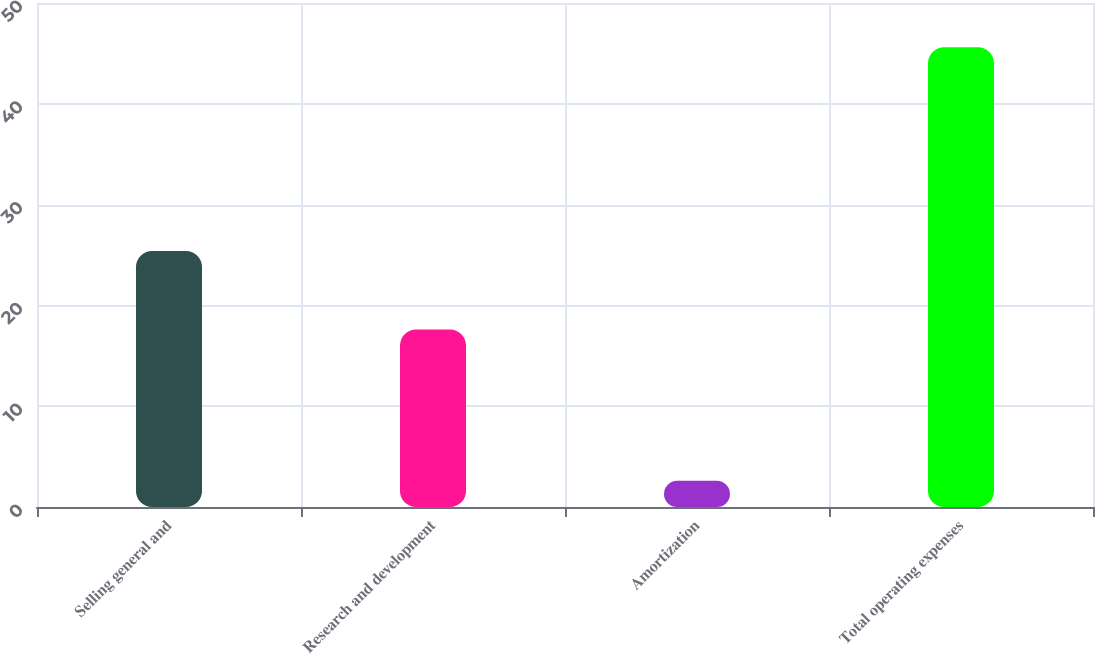<chart> <loc_0><loc_0><loc_500><loc_500><bar_chart><fcel>Selling general and<fcel>Research and development<fcel>Amortization<fcel>Total operating expenses<nl><fcel>25.4<fcel>17.6<fcel>2.6<fcel>45.6<nl></chart> 